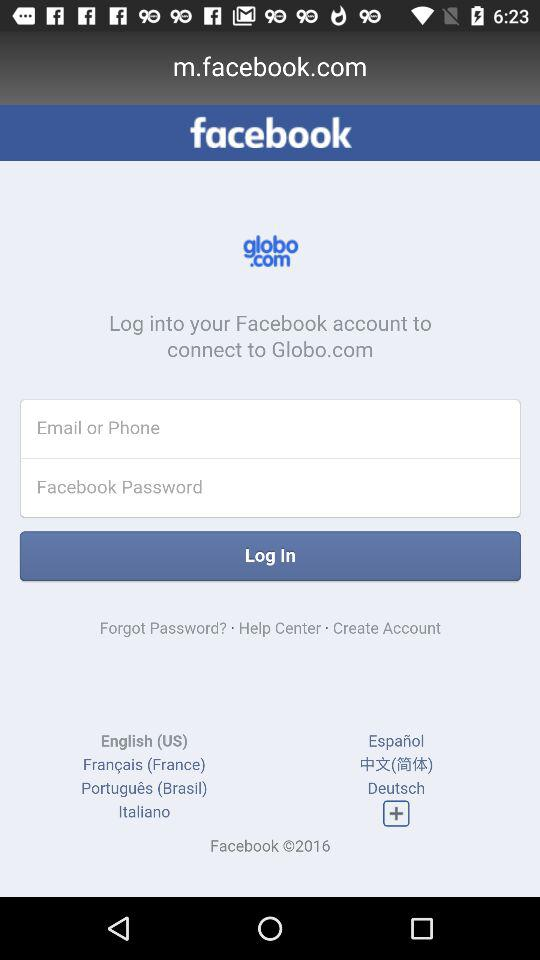Where can we connect by logging into Facebook? We can connect to "Globo.com". 